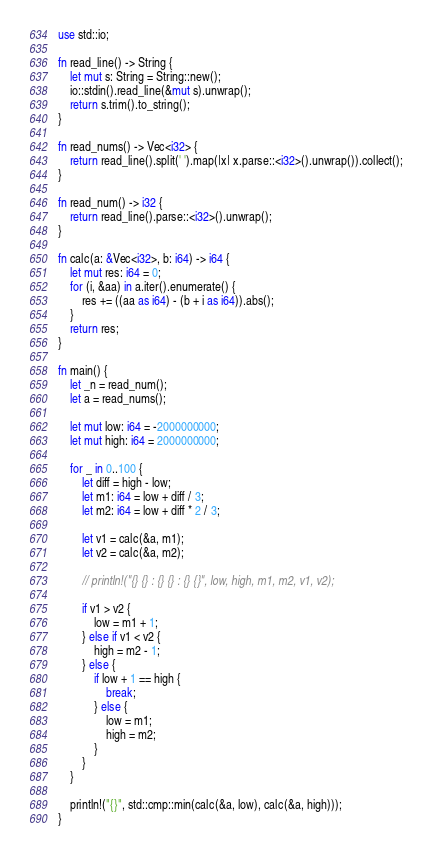Convert code to text. <code><loc_0><loc_0><loc_500><loc_500><_Rust_>use std::io;

fn read_line() -> String {
    let mut s: String = String::new();
    io::stdin().read_line(&mut s).unwrap();
    return s.trim().to_string();
}

fn read_nums() -> Vec<i32> {
    return read_line().split(' ').map(|x| x.parse::<i32>().unwrap()).collect();
}

fn read_num() -> i32 {
    return read_line().parse::<i32>().unwrap();
}

fn calc(a: &Vec<i32>, b: i64) -> i64 {
    let mut res: i64 = 0;
    for (i, &aa) in a.iter().enumerate() {
        res += ((aa as i64) - (b + i as i64)).abs();
    }
    return res;
}

fn main() {
    let _n = read_num();
    let a = read_nums();

    let mut low: i64 = -2000000000;
    let mut high: i64 = 2000000000;

    for _ in 0..100 {
        let diff = high - low;
        let m1: i64 = low + diff / 3;
        let m2: i64 = low + diff * 2 / 3;

        let v1 = calc(&a, m1);
        let v2 = calc(&a, m2);

        // println!("{} {} : {} {} : {} {}", low, high, m1, m2, v1, v2);

        if v1 > v2 {
            low = m1 + 1;
        } else if v1 < v2 {
            high = m2 - 1;
        } else {
            if low + 1 == high {
                break;
            } else {
                low = m1;
                high = m2;
            }
        }
    }

    println!("{}", std::cmp::min(calc(&a, low), calc(&a, high)));
}</code> 